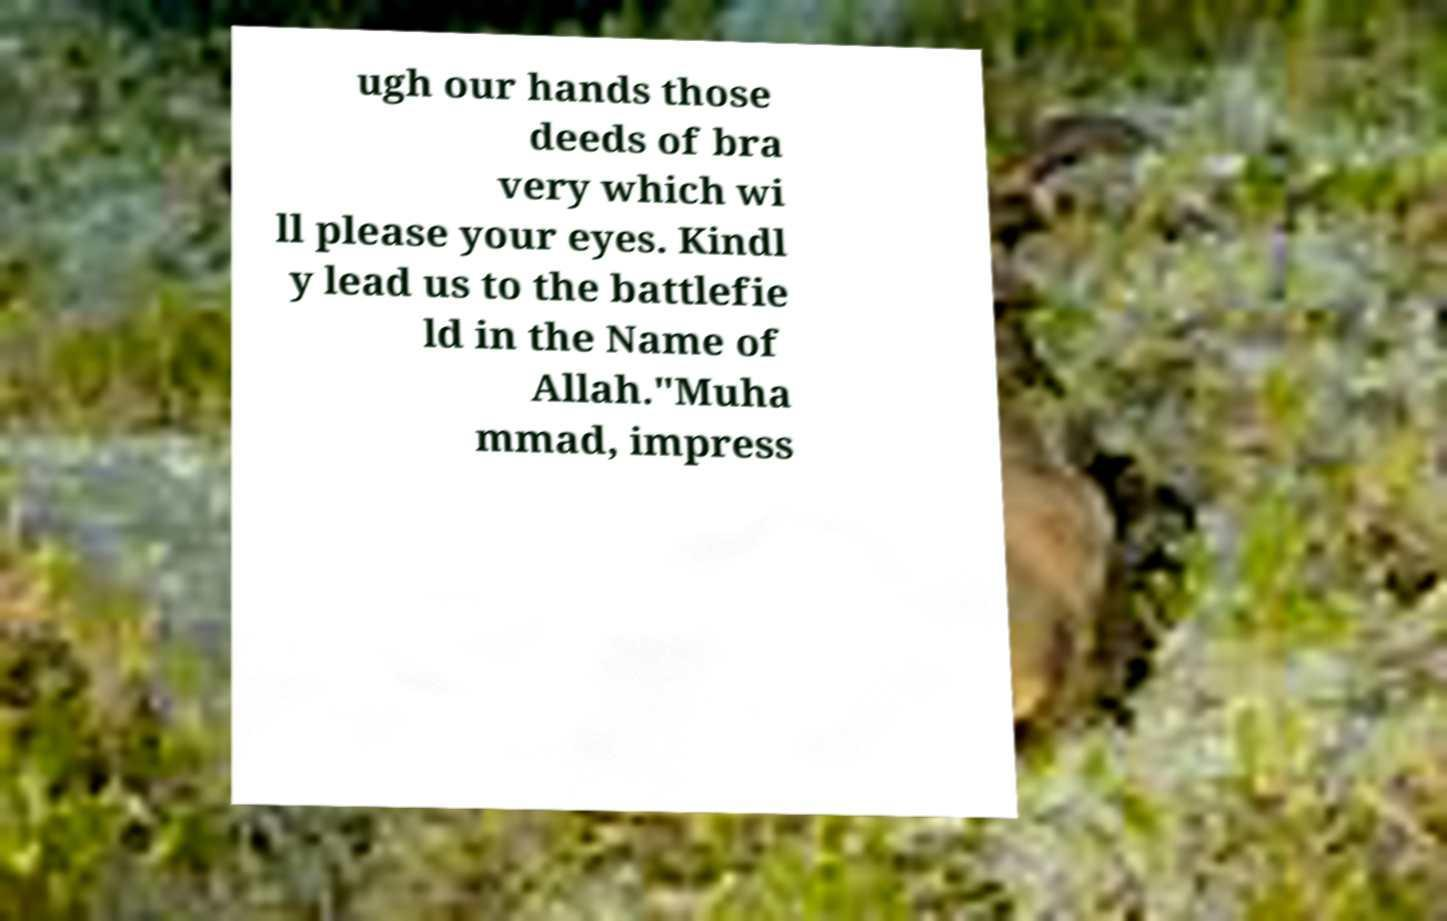Could you extract and type out the text from this image? ugh our hands those deeds of bra very which wi ll please your eyes. Kindl y lead us to the battlefie ld in the Name of Allah."Muha mmad, impress 